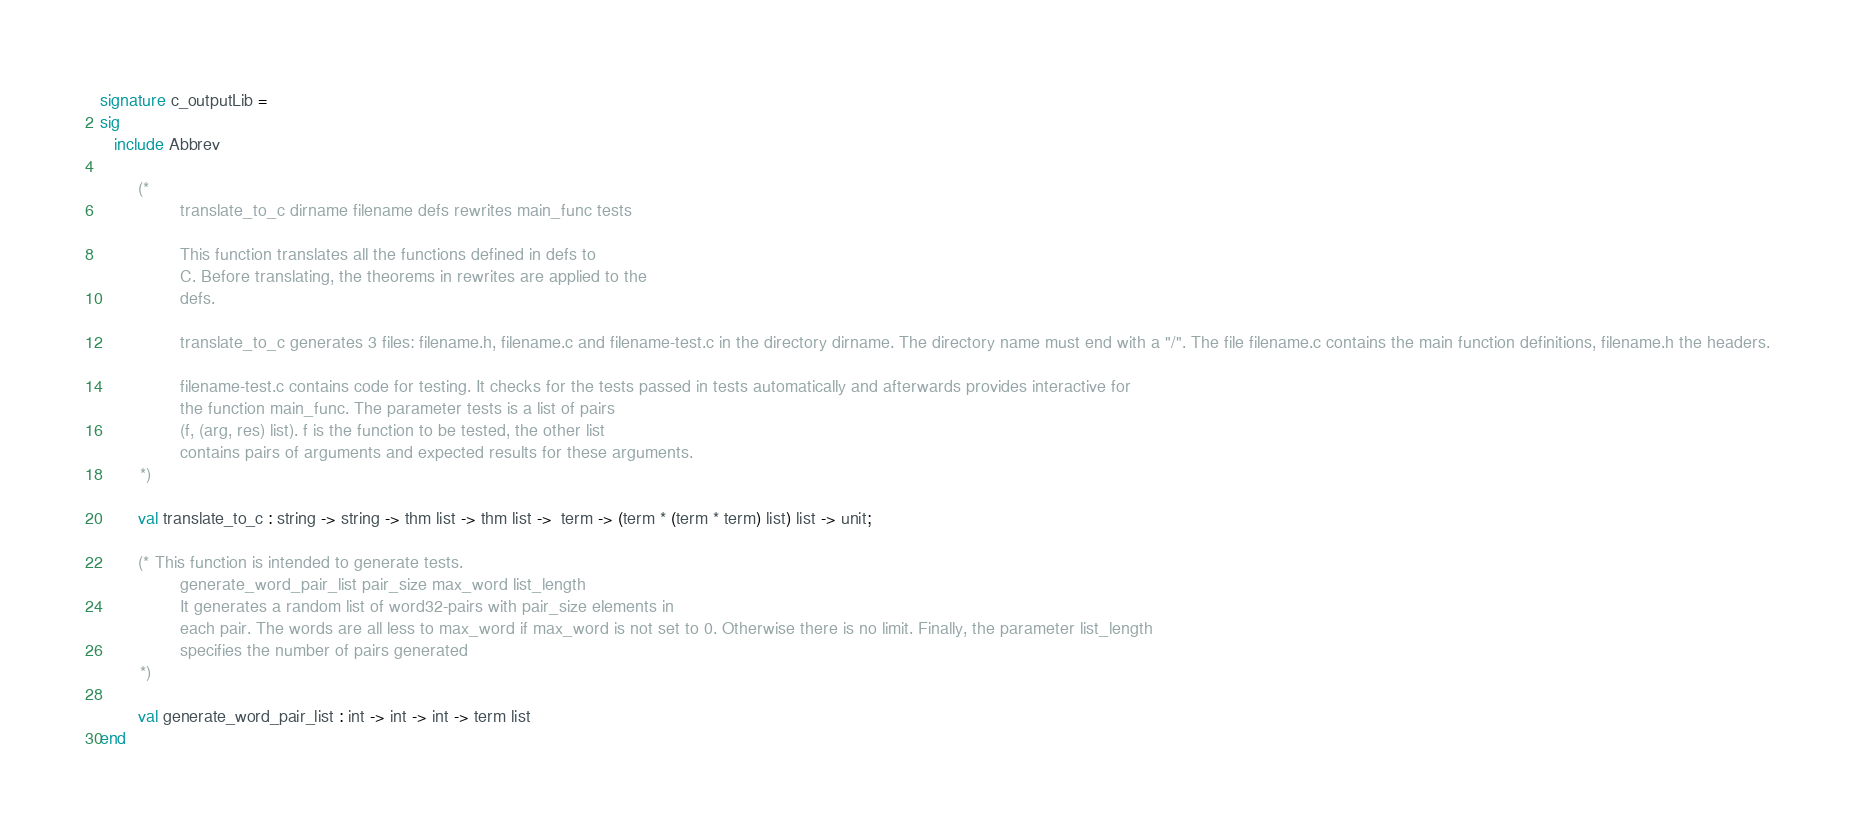<code> <loc_0><loc_0><loc_500><loc_500><_SML_>signature c_outputLib =
sig
   include Abbrev

        (*
                translate_to_c dirname filename defs rewrites main_func tests

                This function translates all the functions defined in defs to
                C. Before translating, the theorems in rewrites are applied to the
                defs.

                translate_to_c generates 3 files: filename.h, filename.c and filename-test.c in the directory dirname. The directory name must end with a "/". The file filename.c contains the main function definitions, filename.h the headers.

                filename-test.c contains code for testing. It checks for the tests passed in tests automatically and afterwards provides interactive for
                the function main_func. The parameter tests is a list of pairs
                (f, (arg, res) list). f is the function to be tested, the other list
                contains pairs of arguments and expected results for these arguments.
        *)

        val translate_to_c : string -> string -> thm list -> thm list ->  term -> (term * (term * term) list) list -> unit;

        (* This function is intended to generate tests.
                generate_word_pair_list pair_size max_word list_length
                It generates a random list of word32-pairs with pair_size elements in
                each pair. The words are all less to max_word if max_word is not set to 0. Otherwise there is no limit. Finally, the parameter list_length
                specifies the number of pairs generated
        *)

        val generate_word_pair_list : int -> int -> int -> term list
end
</code> 